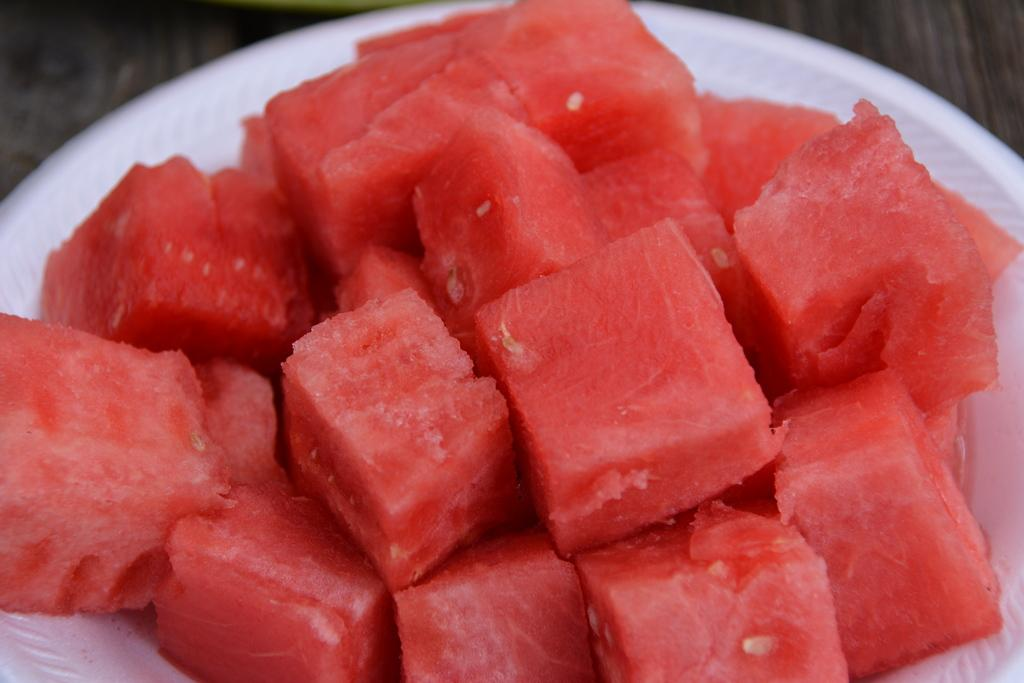What type of food is visible in the image? There are watermelon slices in the image. How are the watermelon slices arranged in the image? The watermelon slices are in a plate. Where is the plate with watermelon slices located? The plate is on a platform. What type of chess piece is visible in the image? There is no chess piece present in the image; it features watermelon slices in a plate on a platform. 